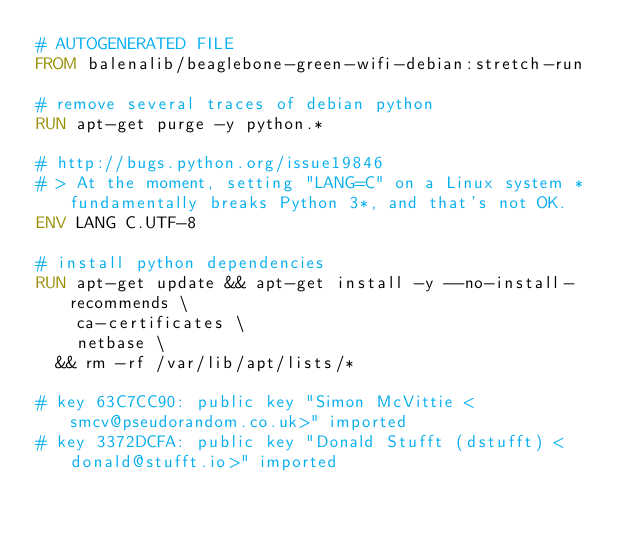Convert code to text. <code><loc_0><loc_0><loc_500><loc_500><_Dockerfile_># AUTOGENERATED FILE
FROM balenalib/beaglebone-green-wifi-debian:stretch-run

# remove several traces of debian python
RUN apt-get purge -y python.*

# http://bugs.python.org/issue19846
# > At the moment, setting "LANG=C" on a Linux system *fundamentally breaks Python 3*, and that's not OK.
ENV LANG C.UTF-8

# install python dependencies
RUN apt-get update && apt-get install -y --no-install-recommends \
		ca-certificates \
		netbase \
	&& rm -rf /var/lib/apt/lists/*

# key 63C7CC90: public key "Simon McVittie <smcv@pseudorandom.co.uk>" imported
# key 3372DCFA: public key "Donald Stufft (dstufft) <donald@stufft.io>" imported</code> 